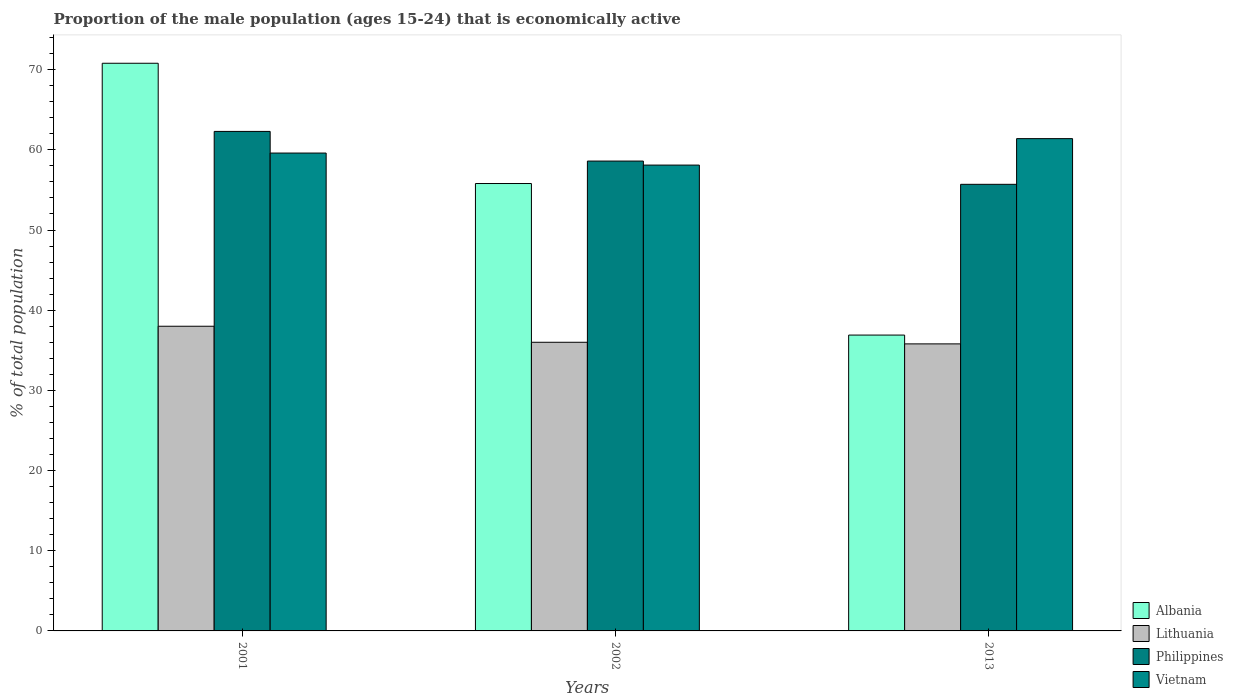Are the number of bars on each tick of the X-axis equal?
Provide a short and direct response. Yes. How many bars are there on the 3rd tick from the right?
Your response must be concise. 4. What is the proportion of the male population that is economically active in Vietnam in 2001?
Your answer should be compact. 59.6. Across all years, what is the maximum proportion of the male population that is economically active in Albania?
Your response must be concise. 70.8. Across all years, what is the minimum proportion of the male population that is economically active in Vietnam?
Provide a succinct answer. 58.1. In which year was the proportion of the male population that is economically active in Albania minimum?
Your response must be concise. 2013. What is the total proportion of the male population that is economically active in Vietnam in the graph?
Make the answer very short. 179.1. What is the difference between the proportion of the male population that is economically active in Albania in 2001 and the proportion of the male population that is economically active in Vietnam in 2013?
Provide a succinct answer. 9.4. What is the average proportion of the male population that is economically active in Philippines per year?
Your answer should be very brief. 58.87. In the year 2002, what is the difference between the proportion of the male population that is economically active in Philippines and proportion of the male population that is economically active in Lithuania?
Provide a short and direct response. 22.6. What is the ratio of the proportion of the male population that is economically active in Albania in 2001 to that in 2013?
Give a very brief answer. 1.92. What is the difference between the highest and the second highest proportion of the male population that is economically active in Philippines?
Your answer should be very brief. 3.7. What is the difference between the highest and the lowest proportion of the male population that is economically active in Philippines?
Offer a terse response. 6.6. Is the sum of the proportion of the male population that is economically active in Vietnam in 2001 and 2013 greater than the maximum proportion of the male population that is economically active in Philippines across all years?
Make the answer very short. Yes. What does the 4th bar from the left in 2001 represents?
Offer a very short reply. Vietnam. What does the 3rd bar from the right in 2013 represents?
Offer a very short reply. Lithuania. Is it the case that in every year, the sum of the proportion of the male population that is economically active in Vietnam and proportion of the male population that is economically active in Philippines is greater than the proportion of the male population that is economically active in Lithuania?
Ensure brevity in your answer.  Yes. How many bars are there?
Your answer should be compact. 12. Are all the bars in the graph horizontal?
Offer a very short reply. No. How many years are there in the graph?
Offer a very short reply. 3. What is the difference between two consecutive major ticks on the Y-axis?
Ensure brevity in your answer.  10. Are the values on the major ticks of Y-axis written in scientific E-notation?
Provide a succinct answer. No. Does the graph contain any zero values?
Offer a very short reply. No. Where does the legend appear in the graph?
Provide a succinct answer. Bottom right. How many legend labels are there?
Your answer should be very brief. 4. How are the legend labels stacked?
Provide a short and direct response. Vertical. What is the title of the graph?
Your response must be concise. Proportion of the male population (ages 15-24) that is economically active. Does "Iran" appear as one of the legend labels in the graph?
Offer a very short reply. No. What is the label or title of the Y-axis?
Give a very brief answer. % of total population. What is the % of total population of Albania in 2001?
Your answer should be very brief. 70.8. What is the % of total population of Lithuania in 2001?
Make the answer very short. 38. What is the % of total population of Philippines in 2001?
Your answer should be very brief. 62.3. What is the % of total population in Vietnam in 2001?
Give a very brief answer. 59.6. What is the % of total population of Albania in 2002?
Your response must be concise. 55.8. What is the % of total population of Lithuania in 2002?
Offer a very short reply. 36. What is the % of total population of Philippines in 2002?
Your response must be concise. 58.6. What is the % of total population in Vietnam in 2002?
Your response must be concise. 58.1. What is the % of total population of Albania in 2013?
Offer a terse response. 36.9. What is the % of total population in Lithuania in 2013?
Offer a very short reply. 35.8. What is the % of total population in Philippines in 2013?
Your answer should be very brief. 55.7. What is the % of total population in Vietnam in 2013?
Your answer should be very brief. 61.4. Across all years, what is the maximum % of total population of Albania?
Ensure brevity in your answer.  70.8. Across all years, what is the maximum % of total population in Lithuania?
Give a very brief answer. 38. Across all years, what is the maximum % of total population in Philippines?
Offer a very short reply. 62.3. Across all years, what is the maximum % of total population of Vietnam?
Offer a terse response. 61.4. Across all years, what is the minimum % of total population in Albania?
Offer a very short reply. 36.9. Across all years, what is the minimum % of total population of Lithuania?
Offer a very short reply. 35.8. Across all years, what is the minimum % of total population in Philippines?
Ensure brevity in your answer.  55.7. Across all years, what is the minimum % of total population of Vietnam?
Your answer should be compact. 58.1. What is the total % of total population in Albania in the graph?
Your answer should be very brief. 163.5. What is the total % of total population of Lithuania in the graph?
Your answer should be compact. 109.8. What is the total % of total population in Philippines in the graph?
Give a very brief answer. 176.6. What is the total % of total population in Vietnam in the graph?
Offer a very short reply. 179.1. What is the difference between the % of total population of Lithuania in 2001 and that in 2002?
Give a very brief answer. 2. What is the difference between the % of total population in Philippines in 2001 and that in 2002?
Offer a very short reply. 3.7. What is the difference between the % of total population of Vietnam in 2001 and that in 2002?
Your answer should be very brief. 1.5. What is the difference between the % of total population in Albania in 2001 and that in 2013?
Offer a very short reply. 33.9. What is the difference between the % of total population of Lithuania in 2001 and that in 2013?
Your response must be concise. 2.2. What is the difference between the % of total population in Philippines in 2001 and that in 2013?
Offer a terse response. 6.6. What is the difference between the % of total population of Vietnam in 2001 and that in 2013?
Give a very brief answer. -1.8. What is the difference between the % of total population in Albania in 2002 and that in 2013?
Offer a terse response. 18.9. What is the difference between the % of total population in Philippines in 2002 and that in 2013?
Your answer should be very brief. 2.9. What is the difference between the % of total population in Vietnam in 2002 and that in 2013?
Make the answer very short. -3.3. What is the difference between the % of total population of Albania in 2001 and the % of total population of Lithuania in 2002?
Keep it short and to the point. 34.8. What is the difference between the % of total population of Albania in 2001 and the % of total population of Vietnam in 2002?
Offer a terse response. 12.7. What is the difference between the % of total population of Lithuania in 2001 and the % of total population of Philippines in 2002?
Keep it short and to the point. -20.6. What is the difference between the % of total population of Lithuania in 2001 and the % of total population of Vietnam in 2002?
Offer a very short reply. -20.1. What is the difference between the % of total population in Philippines in 2001 and the % of total population in Vietnam in 2002?
Keep it short and to the point. 4.2. What is the difference between the % of total population of Albania in 2001 and the % of total population of Philippines in 2013?
Ensure brevity in your answer.  15.1. What is the difference between the % of total population in Albania in 2001 and the % of total population in Vietnam in 2013?
Your response must be concise. 9.4. What is the difference between the % of total population of Lithuania in 2001 and the % of total population of Philippines in 2013?
Make the answer very short. -17.7. What is the difference between the % of total population of Lithuania in 2001 and the % of total population of Vietnam in 2013?
Offer a very short reply. -23.4. What is the difference between the % of total population of Albania in 2002 and the % of total population of Lithuania in 2013?
Keep it short and to the point. 20. What is the difference between the % of total population in Albania in 2002 and the % of total population in Vietnam in 2013?
Ensure brevity in your answer.  -5.6. What is the difference between the % of total population of Lithuania in 2002 and the % of total population of Philippines in 2013?
Your response must be concise. -19.7. What is the difference between the % of total population in Lithuania in 2002 and the % of total population in Vietnam in 2013?
Provide a succinct answer. -25.4. What is the average % of total population in Albania per year?
Your answer should be very brief. 54.5. What is the average % of total population of Lithuania per year?
Your answer should be compact. 36.6. What is the average % of total population of Philippines per year?
Make the answer very short. 58.87. What is the average % of total population of Vietnam per year?
Your response must be concise. 59.7. In the year 2001, what is the difference between the % of total population in Albania and % of total population in Lithuania?
Give a very brief answer. 32.8. In the year 2001, what is the difference between the % of total population in Lithuania and % of total population in Philippines?
Your answer should be very brief. -24.3. In the year 2001, what is the difference between the % of total population of Lithuania and % of total population of Vietnam?
Your answer should be compact. -21.6. In the year 2002, what is the difference between the % of total population of Albania and % of total population of Lithuania?
Keep it short and to the point. 19.8. In the year 2002, what is the difference between the % of total population in Albania and % of total population in Vietnam?
Provide a succinct answer. -2.3. In the year 2002, what is the difference between the % of total population of Lithuania and % of total population of Philippines?
Offer a terse response. -22.6. In the year 2002, what is the difference between the % of total population of Lithuania and % of total population of Vietnam?
Your answer should be very brief. -22.1. In the year 2013, what is the difference between the % of total population of Albania and % of total population of Lithuania?
Provide a short and direct response. 1.1. In the year 2013, what is the difference between the % of total population in Albania and % of total population in Philippines?
Your answer should be compact. -18.8. In the year 2013, what is the difference between the % of total population of Albania and % of total population of Vietnam?
Your answer should be compact. -24.5. In the year 2013, what is the difference between the % of total population of Lithuania and % of total population of Philippines?
Offer a very short reply. -19.9. In the year 2013, what is the difference between the % of total population of Lithuania and % of total population of Vietnam?
Your response must be concise. -25.6. What is the ratio of the % of total population in Albania in 2001 to that in 2002?
Offer a very short reply. 1.27. What is the ratio of the % of total population in Lithuania in 2001 to that in 2002?
Provide a succinct answer. 1.06. What is the ratio of the % of total population of Philippines in 2001 to that in 2002?
Provide a short and direct response. 1.06. What is the ratio of the % of total population of Vietnam in 2001 to that in 2002?
Keep it short and to the point. 1.03. What is the ratio of the % of total population in Albania in 2001 to that in 2013?
Give a very brief answer. 1.92. What is the ratio of the % of total population of Lithuania in 2001 to that in 2013?
Keep it short and to the point. 1.06. What is the ratio of the % of total population in Philippines in 2001 to that in 2013?
Offer a terse response. 1.12. What is the ratio of the % of total population in Vietnam in 2001 to that in 2013?
Offer a terse response. 0.97. What is the ratio of the % of total population in Albania in 2002 to that in 2013?
Ensure brevity in your answer.  1.51. What is the ratio of the % of total population of Lithuania in 2002 to that in 2013?
Your answer should be very brief. 1.01. What is the ratio of the % of total population in Philippines in 2002 to that in 2013?
Ensure brevity in your answer.  1.05. What is the ratio of the % of total population of Vietnam in 2002 to that in 2013?
Ensure brevity in your answer.  0.95. What is the difference between the highest and the second highest % of total population in Lithuania?
Offer a terse response. 2. What is the difference between the highest and the second highest % of total population in Vietnam?
Ensure brevity in your answer.  1.8. What is the difference between the highest and the lowest % of total population of Albania?
Your response must be concise. 33.9. What is the difference between the highest and the lowest % of total population in Philippines?
Provide a succinct answer. 6.6. 